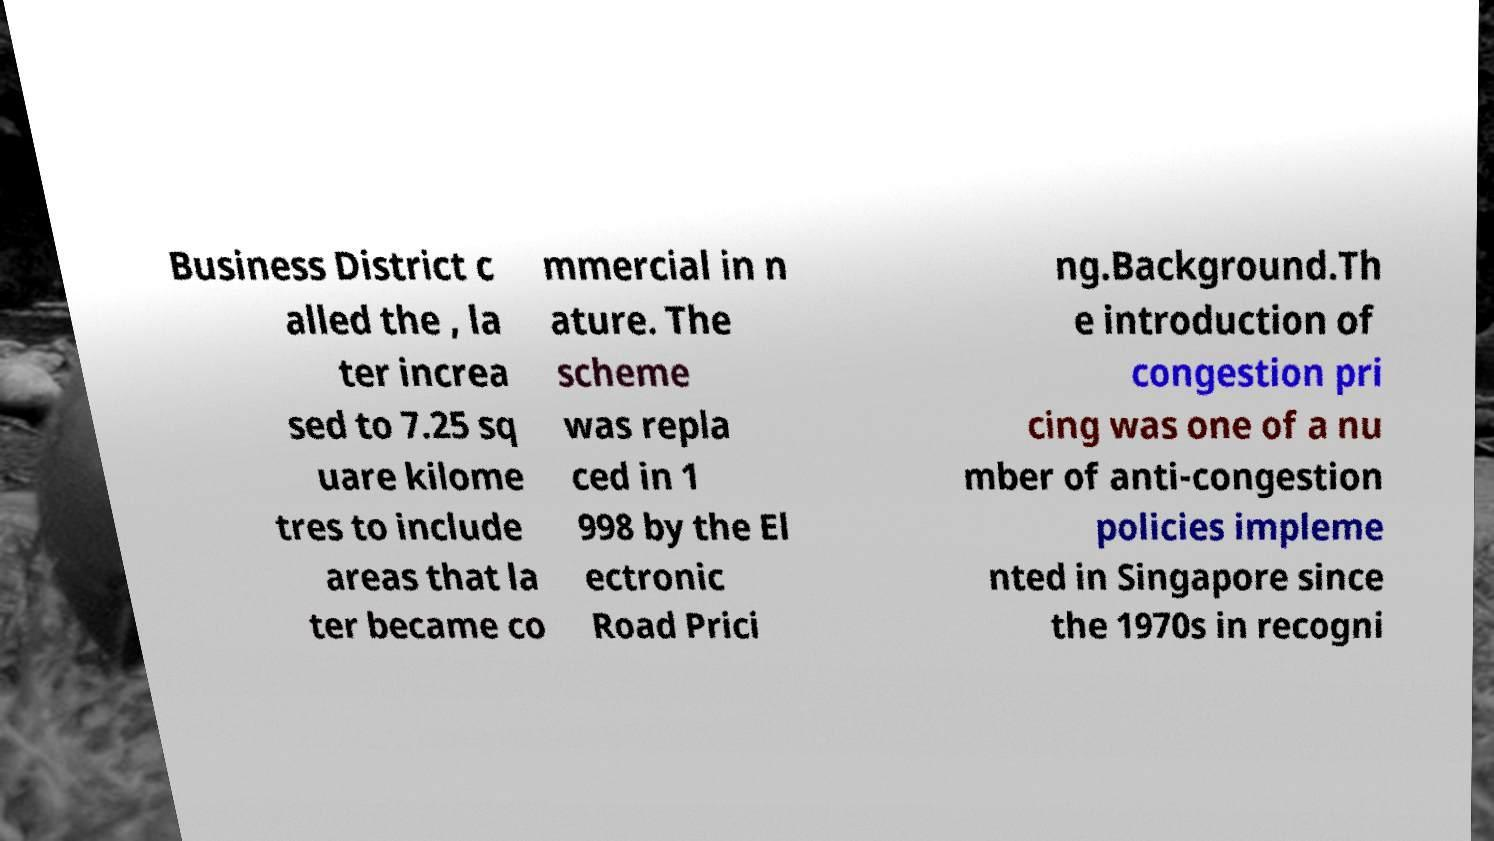I need the written content from this picture converted into text. Can you do that? Business District c alled the , la ter increa sed to 7.25 sq uare kilome tres to include areas that la ter became co mmercial in n ature. The scheme was repla ced in 1 998 by the El ectronic Road Prici ng.Background.Th e introduction of congestion pri cing was one of a nu mber of anti-congestion policies impleme nted in Singapore since the 1970s in recogni 